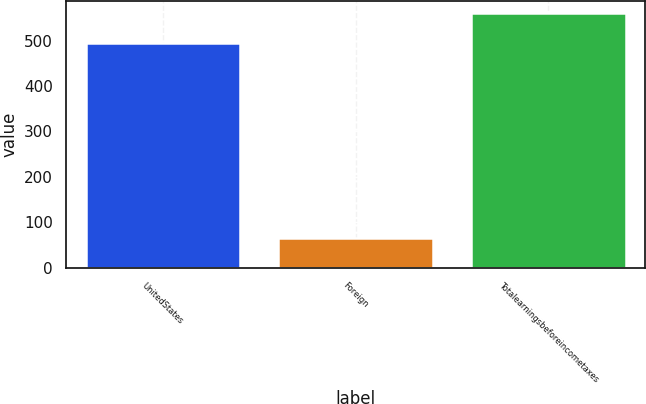<chart> <loc_0><loc_0><loc_500><loc_500><bar_chart><fcel>UnitedStates<fcel>Foreign<fcel>Totalearningsbeforeincometaxes<nl><fcel>494.6<fcel>65.3<fcel>559.9<nl></chart> 